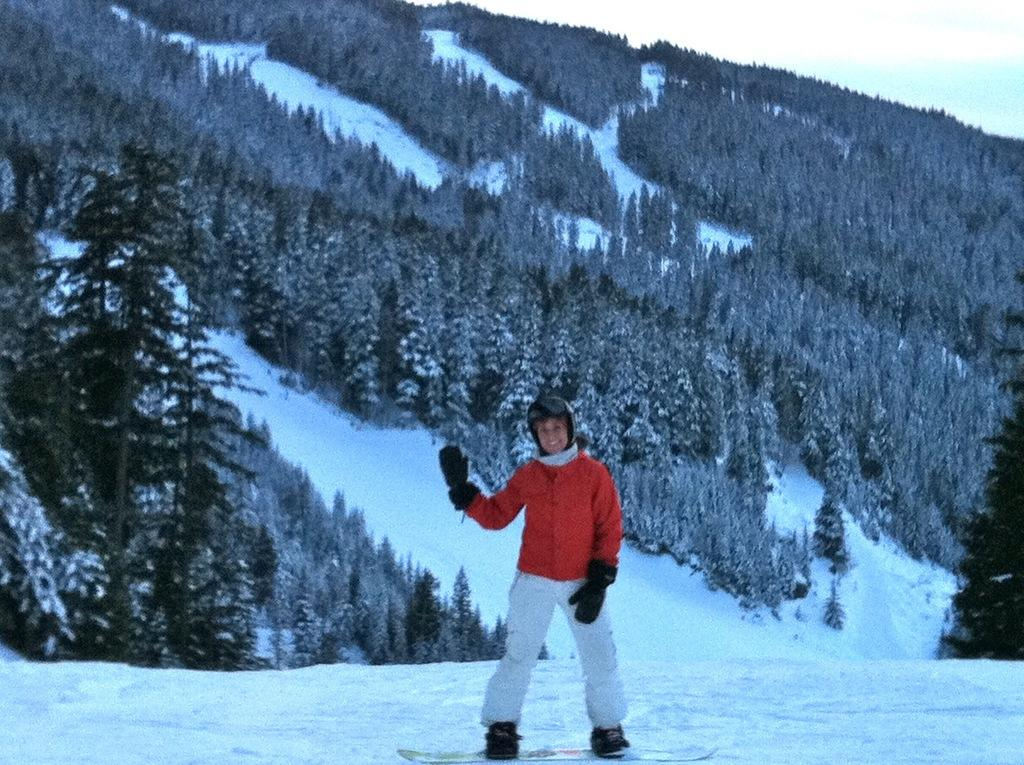What is the main subject of the image? There is a person in the image. What is the person doing in the image? The person is standing on a ski board. What is the ski board resting on? The ski board is on the snow. What can be seen in the background of the image? There is snow, trees, and the sky visible in the background of the image. What type of umbrella is the person holding in the image? There is no umbrella present in the image. How many cubs are visible playing with tomatoes in the image? There are no cubs or tomatoes present in the image. 